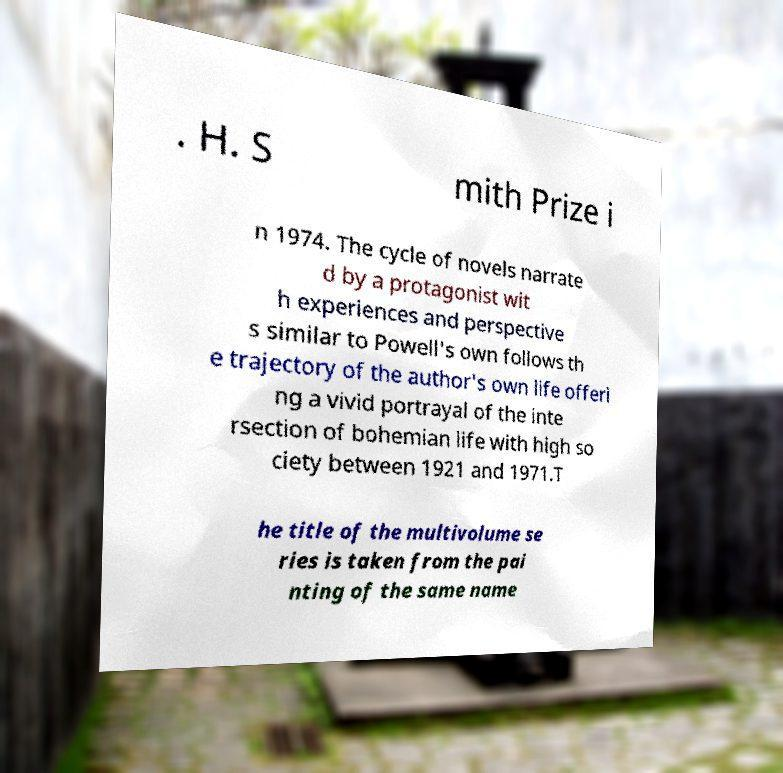There's text embedded in this image that I need extracted. Can you transcribe it verbatim? . H. S mith Prize i n 1974. The cycle of novels narrate d by a protagonist wit h experiences and perspective s similar to Powell's own follows th e trajectory of the author's own life offeri ng a vivid portrayal of the inte rsection of bohemian life with high so ciety between 1921 and 1971.T he title of the multivolume se ries is taken from the pai nting of the same name 